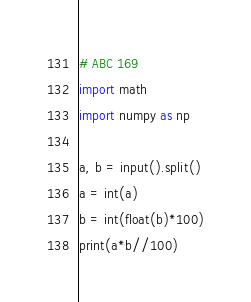<code> <loc_0><loc_0><loc_500><loc_500><_Python_># ABC 169
import math
import numpy as np

a, b = input().split()
a = int(a)
b = int(float(b)*100)
print(a*b//100)</code> 